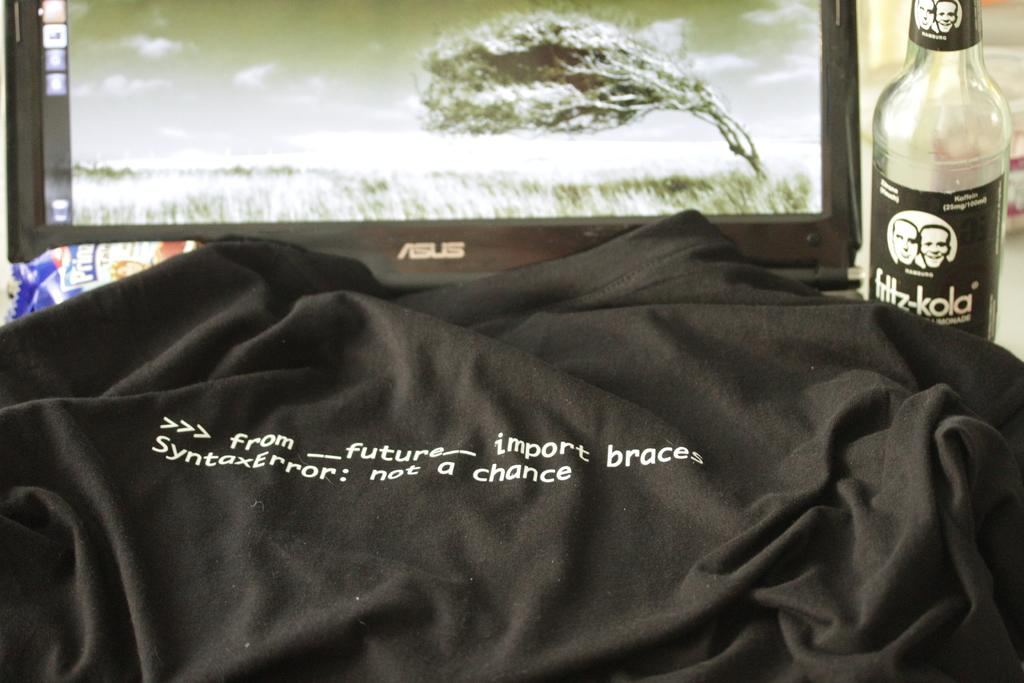What type of clothing item is visible in the image? There is a t-shirt in the image. What type of container is present in the image? There is a bottle in the image. What type of electronic device is visible in the image? There is a monitor in the image. What type of mark can be seen on the car in the image? There is no car present in the image. What type of shade is covering the monitor in the image? There is no shade covering the monitor in the image. 